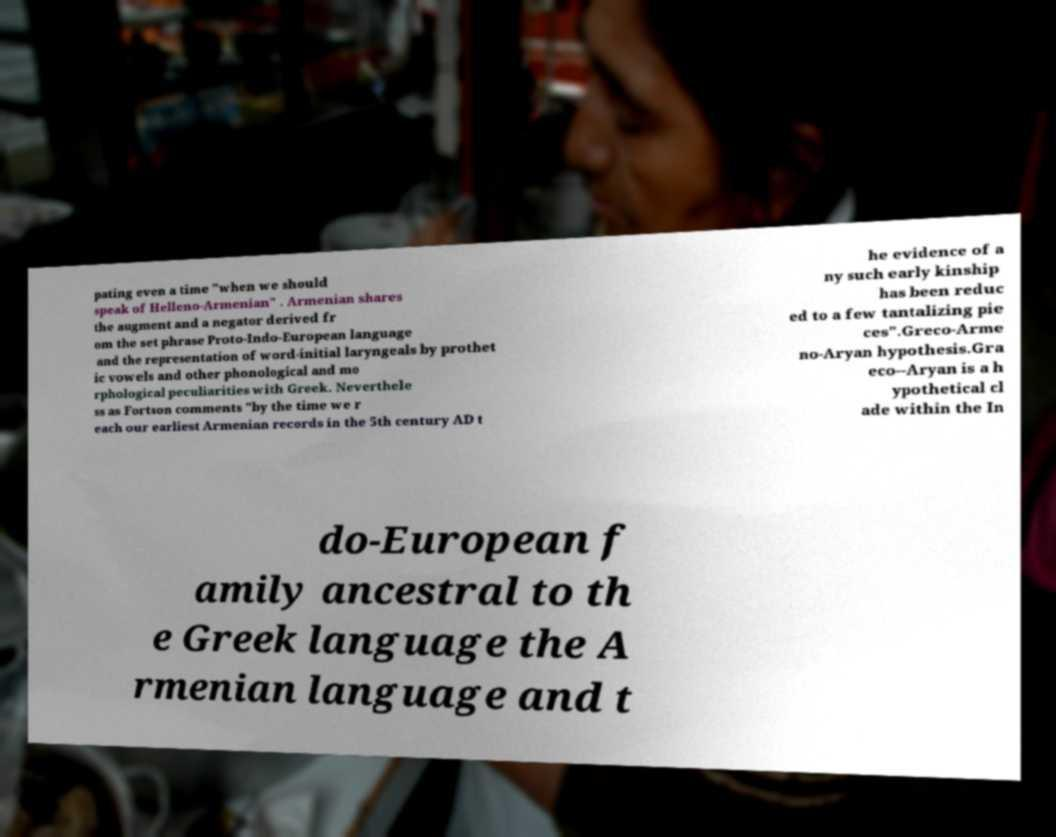Can you read and provide the text displayed in the image?This photo seems to have some interesting text. Can you extract and type it out for me? pating even a time "when we should speak of Helleno-Armenian" . Armenian shares the augment and a negator derived fr om the set phrase Proto-Indo-European language and the representation of word-initial laryngeals by prothet ic vowels and other phonological and mo rphological peculiarities with Greek. Neverthele ss as Fortson comments "by the time we r each our earliest Armenian records in the 5th century AD t he evidence of a ny such early kinship has been reduc ed to a few tantalizing pie ces".Greco-Arme no-Aryan hypothesis.Gra eco--Aryan is a h ypothetical cl ade within the In do-European f amily ancestral to th e Greek language the A rmenian language and t 